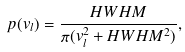<formula> <loc_0><loc_0><loc_500><loc_500>p ( v _ { l } ) = \frac { H W H M } { \pi ( v _ { l } ^ { 2 } + H W H M ^ { 2 } ) } ,</formula> 